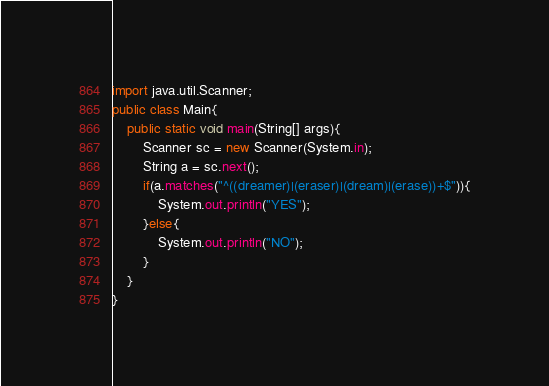Convert code to text. <code><loc_0><loc_0><loc_500><loc_500><_Java_>import java.util.Scanner;
public class Main{
	public static void main(String[] args){
		Scanner sc = new Scanner(System.in);
		String a = sc.next();
		if(a.matches("^((dreamer)|(eraser)|(dream)|(erase))+$")){
			System.out.println("YES");
		}else{
			System.out.println("NO");
		}
	}
}</code> 